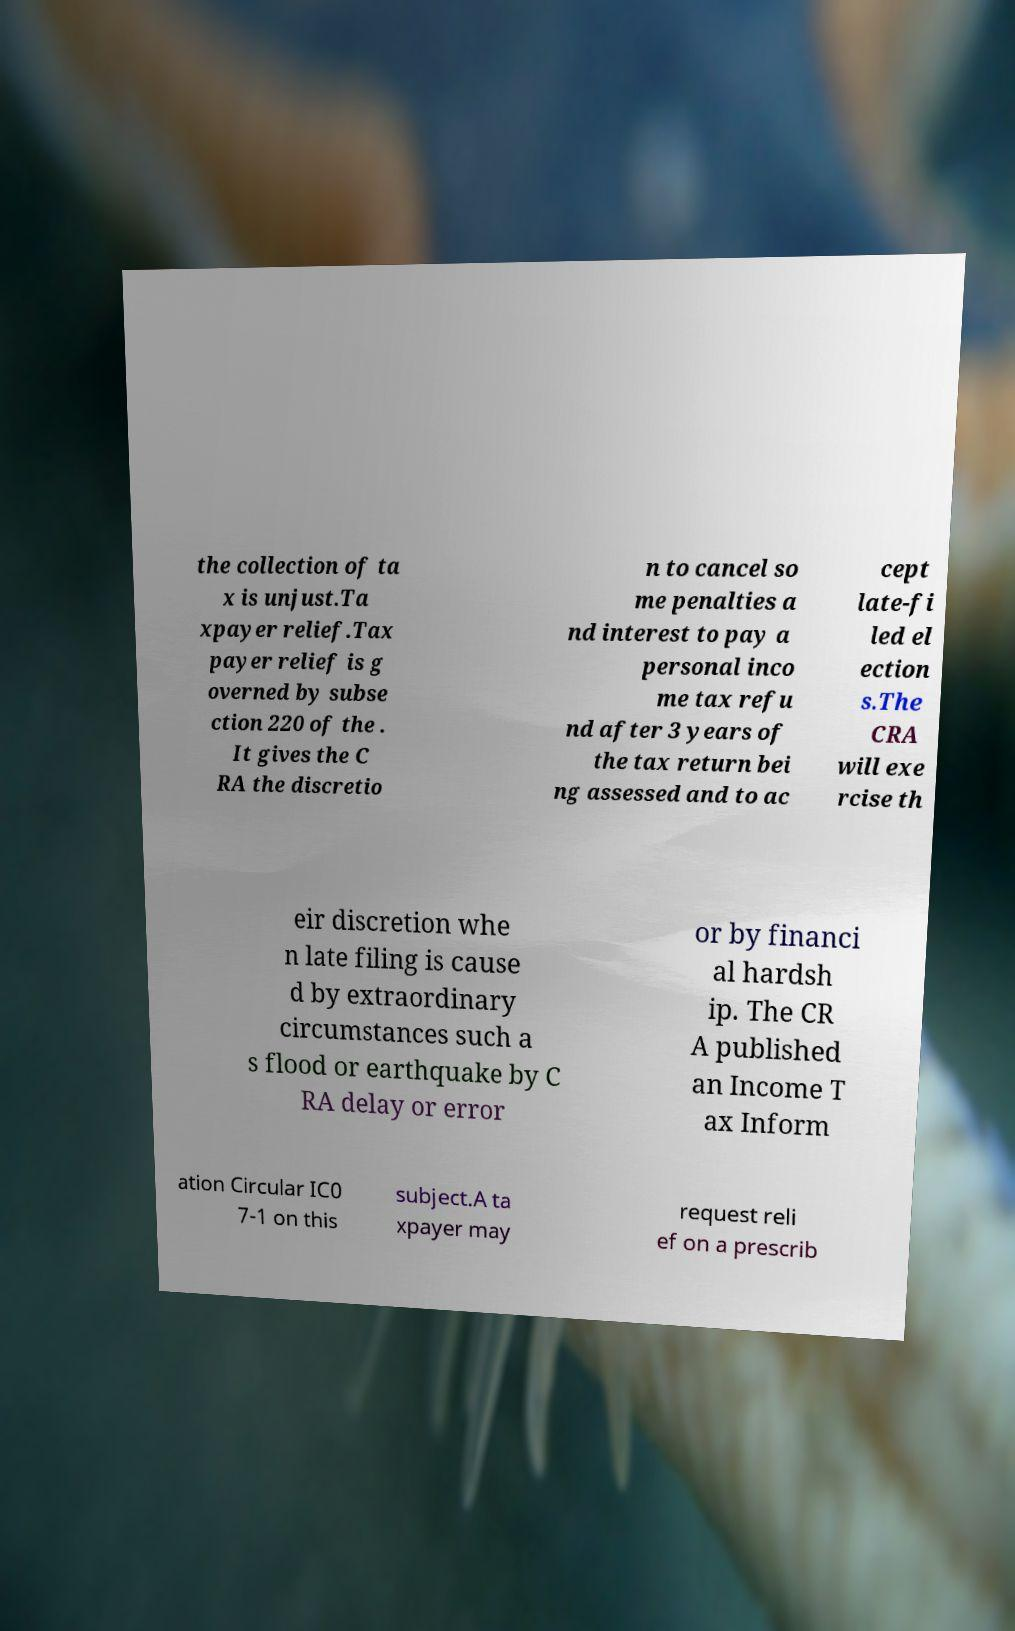Please read and relay the text visible in this image. What does it say? the collection of ta x is unjust.Ta xpayer relief.Tax payer relief is g overned by subse ction 220 of the . It gives the C RA the discretio n to cancel so me penalties a nd interest to pay a personal inco me tax refu nd after 3 years of the tax return bei ng assessed and to ac cept late-fi led el ection s.The CRA will exe rcise th eir discretion whe n late filing is cause d by extraordinary circumstances such a s flood or earthquake by C RA delay or error or by financi al hardsh ip. The CR A published an Income T ax Inform ation Circular IC0 7-1 on this subject.A ta xpayer may request reli ef on a prescrib 